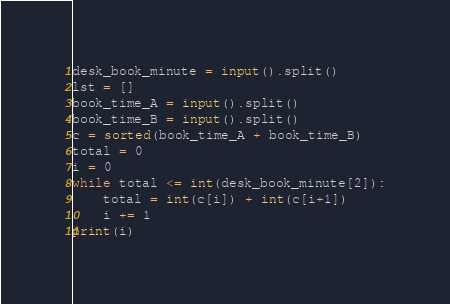<code> <loc_0><loc_0><loc_500><loc_500><_Python_>desk_book_minute = input().split()
lst = []
book_time_A = input().split()
book_time_B = input().split()
c = sorted(book_time_A + book_time_B)
total = 0
i = 0
while total <= int(desk_book_minute[2]):
    total = int(c[i]) + int(c[i+1])
    i += 1
print(i)






</code> 